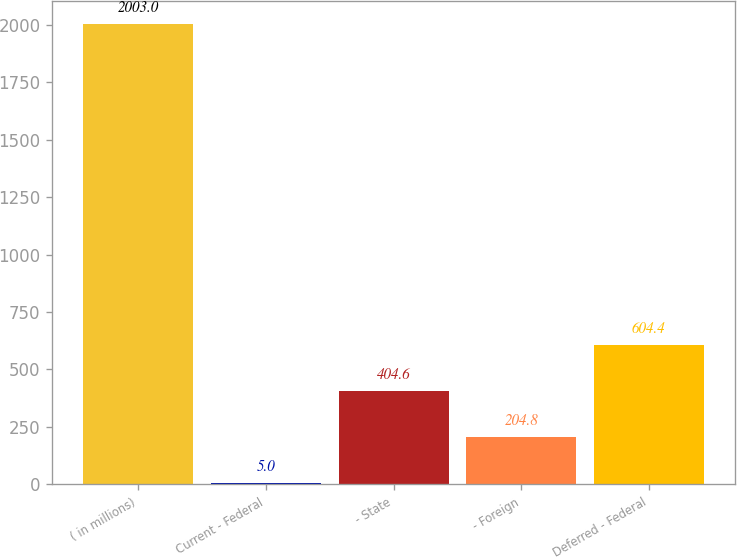Convert chart to OTSL. <chart><loc_0><loc_0><loc_500><loc_500><bar_chart><fcel>( in millions)<fcel>Current - Federal<fcel>- State<fcel>- Foreign<fcel>Deferred - Federal<nl><fcel>2003<fcel>5<fcel>404.6<fcel>204.8<fcel>604.4<nl></chart> 